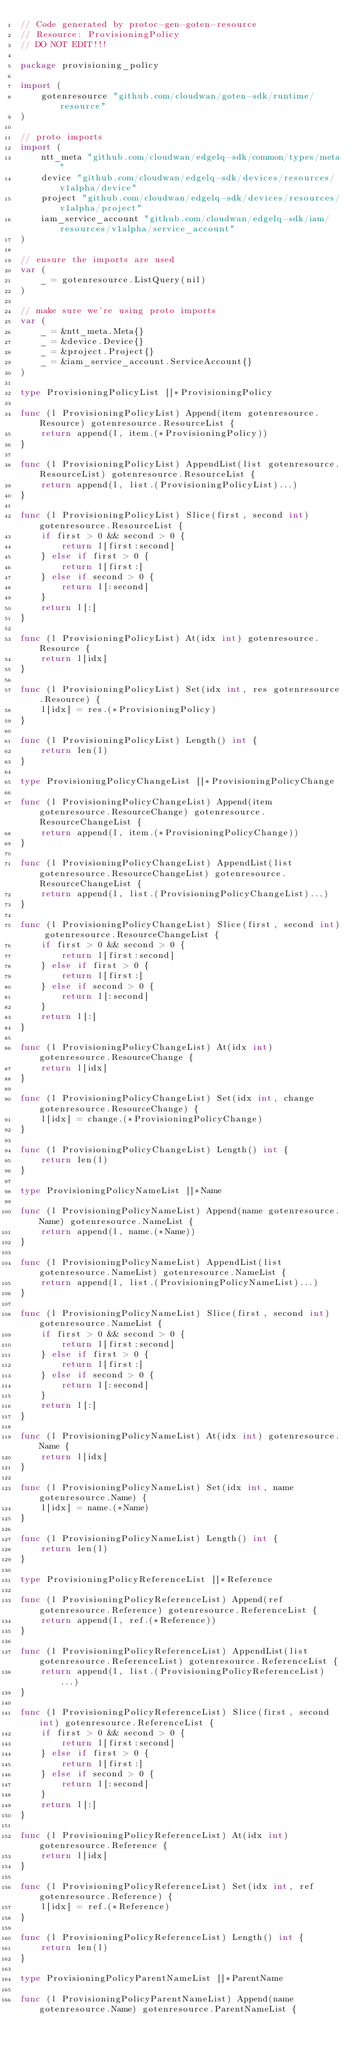<code> <loc_0><loc_0><loc_500><loc_500><_Go_>// Code generated by protoc-gen-goten-resource
// Resource: ProvisioningPolicy
// DO NOT EDIT!!!

package provisioning_policy

import (
	gotenresource "github.com/cloudwan/goten-sdk/runtime/resource"
)

// proto imports
import (
	ntt_meta "github.com/cloudwan/edgelq-sdk/common/types/meta"
	device "github.com/cloudwan/edgelq-sdk/devices/resources/v1alpha/device"
	project "github.com/cloudwan/edgelq-sdk/devices/resources/v1alpha/project"
	iam_service_account "github.com/cloudwan/edgelq-sdk/iam/resources/v1alpha/service_account"
)

// ensure the imports are used
var (
	_ = gotenresource.ListQuery(nil)
)

// make sure we're using proto imports
var (
	_ = &ntt_meta.Meta{}
	_ = &device.Device{}
	_ = &project.Project{}
	_ = &iam_service_account.ServiceAccount{}
)

type ProvisioningPolicyList []*ProvisioningPolicy

func (l ProvisioningPolicyList) Append(item gotenresource.Resource) gotenresource.ResourceList {
	return append(l, item.(*ProvisioningPolicy))
}

func (l ProvisioningPolicyList) AppendList(list gotenresource.ResourceList) gotenresource.ResourceList {
	return append(l, list.(ProvisioningPolicyList)...)
}

func (l ProvisioningPolicyList) Slice(first, second int) gotenresource.ResourceList {
	if first > 0 && second > 0 {
		return l[first:second]
	} else if first > 0 {
		return l[first:]
	} else if second > 0 {
		return l[:second]
	}
	return l[:]
}

func (l ProvisioningPolicyList) At(idx int) gotenresource.Resource {
	return l[idx]
}

func (l ProvisioningPolicyList) Set(idx int, res gotenresource.Resource) {
	l[idx] = res.(*ProvisioningPolicy)
}

func (l ProvisioningPolicyList) Length() int {
	return len(l)
}

type ProvisioningPolicyChangeList []*ProvisioningPolicyChange

func (l ProvisioningPolicyChangeList) Append(item gotenresource.ResourceChange) gotenresource.ResourceChangeList {
	return append(l, item.(*ProvisioningPolicyChange))
}

func (l ProvisioningPolicyChangeList) AppendList(list gotenresource.ResourceChangeList) gotenresource.ResourceChangeList {
	return append(l, list.(ProvisioningPolicyChangeList)...)
}

func (l ProvisioningPolicyChangeList) Slice(first, second int) gotenresource.ResourceChangeList {
	if first > 0 && second > 0 {
		return l[first:second]
	} else if first > 0 {
		return l[first:]
	} else if second > 0 {
		return l[:second]
	}
	return l[:]
}

func (l ProvisioningPolicyChangeList) At(idx int) gotenresource.ResourceChange {
	return l[idx]
}

func (l ProvisioningPolicyChangeList) Set(idx int, change gotenresource.ResourceChange) {
	l[idx] = change.(*ProvisioningPolicyChange)
}

func (l ProvisioningPolicyChangeList) Length() int {
	return len(l)
}

type ProvisioningPolicyNameList []*Name

func (l ProvisioningPolicyNameList) Append(name gotenresource.Name) gotenresource.NameList {
	return append(l, name.(*Name))
}

func (l ProvisioningPolicyNameList) AppendList(list gotenresource.NameList) gotenresource.NameList {
	return append(l, list.(ProvisioningPolicyNameList)...)
}

func (l ProvisioningPolicyNameList) Slice(first, second int) gotenresource.NameList {
	if first > 0 && second > 0 {
		return l[first:second]
	} else if first > 0 {
		return l[first:]
	} else if second > 0 {
		return l[:second]
	}
	return l[:]
}

func (l ProvisioningPolicyNameList) At(idx int) gotenresource.Name {
	return l[idx]
}

func (l ProvisioningPolicyNameList) Set(idx int, name gotenresource.Name) {
	l[idx] = name.(*Name)
}

func (l ProvisioningPolicyNameList) Length() int {
	return len(l)
}

type ProvisioningPolicyReferenceList []*Reference

func (l ProvisioningPolicyReferenceList) Append(ref gotenresource.Reference) gotenresource.ReferenceList {
	return append(l, ref.(*Reference))
}

func (l ProvisioningPolicyReferenceList) AppendList(list gotenresource.ReferenceList) gotenresource.ReferenceList {
	return append(l, list.(ProvisioningPolicyReferenceList)...)
}

func (l ProvisioningPolicyReferenceList) Slice(first, second int) gotenresource.ReferenceList {
	if first > 0 && second > 0 {
		return l[first:second]
	} else if first > 0 {
		return l[first:]
	} else if second > 0 {
		return l[:second]
	}
	return l[:]
}

func (l ProvisioningPolicyReferenceList) At(idx int) gotenresource.Reference {
	return l[idx]
}

func (l ProvisioningPolicyReferenceList) Set(idx int, ref gotenresource.Reference) {
	l[idx] = ref.(*Reference)
}

func (l ProvisioningPolicyReferenceList) Length() int {
	return len(l)
}

type ProvisioningPolicyParentNameList []*ParentName

func (l ProvisioningPolicyParentNameList) Append(name gotenresource.Name) gotenresource.ParentNameList {</code> 